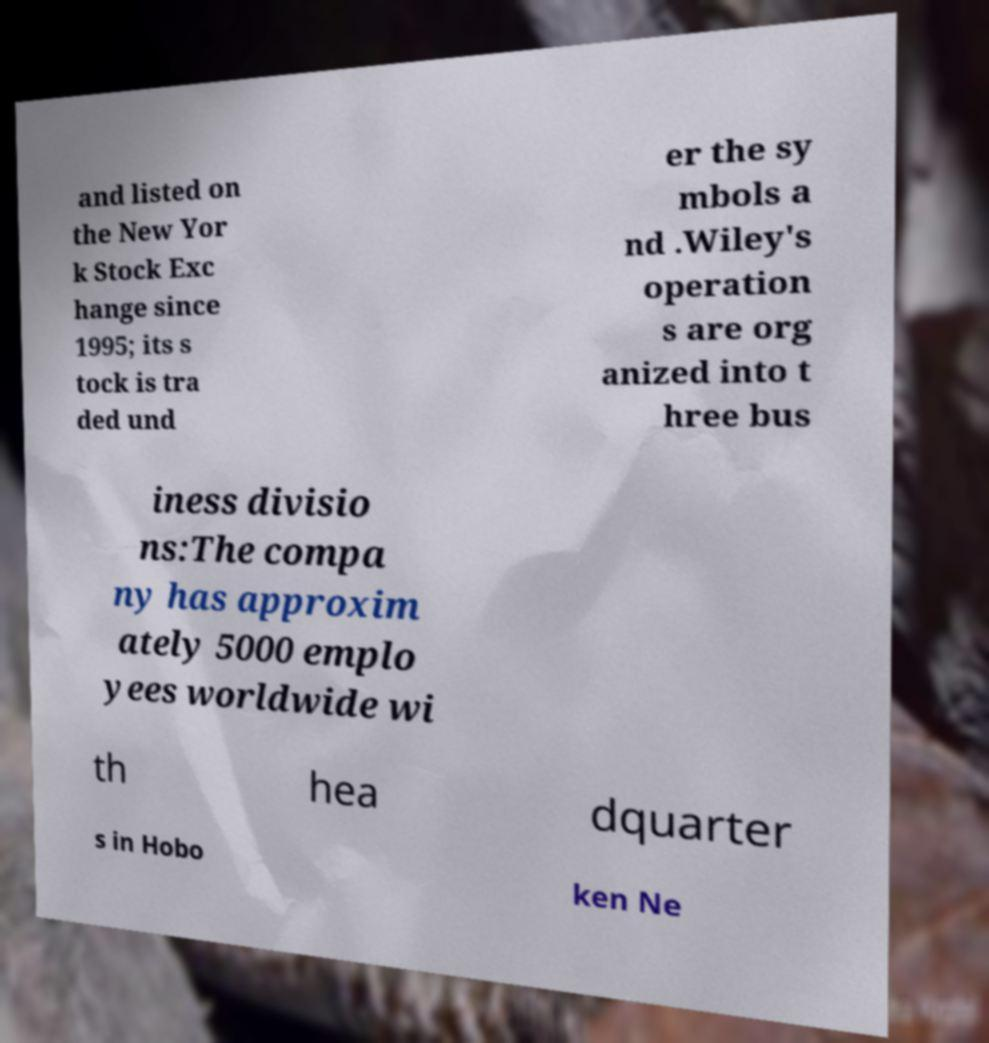Can you read and provide the text displayed in the image?This photo seems to have some interesting text. Can you extract and type it out for me? and listed on the New Yor k Stock Exc hange since 1995; its s tock is tra ded und er the sy mbols a nd .Wiley's operation s are org anized into t hree bus iness divisio ns:The compa ny has approxim ately 5000 emplo yees worldwide wi th hea dquarter s in Hobo ken Ne 